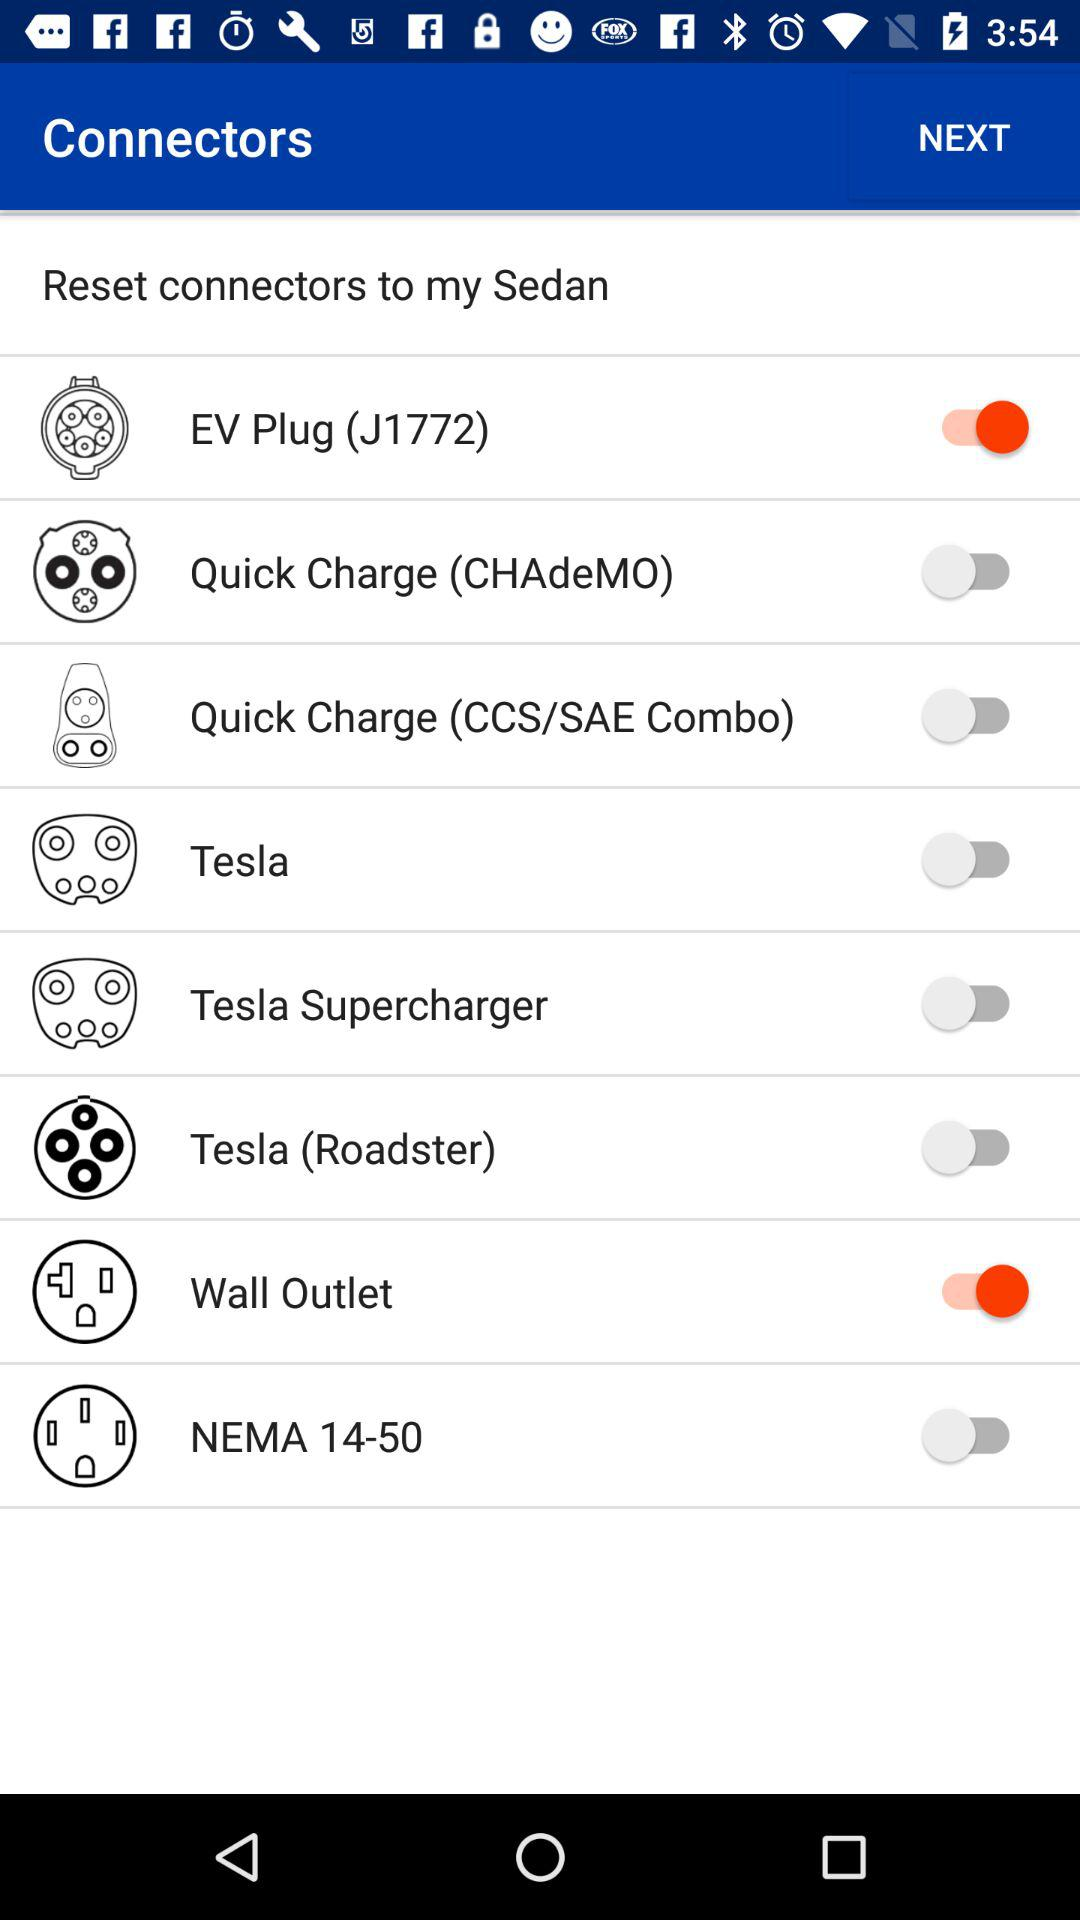What is the name of the user?
When the provided information is insufficient, respond with <no answer>. <no answer> 